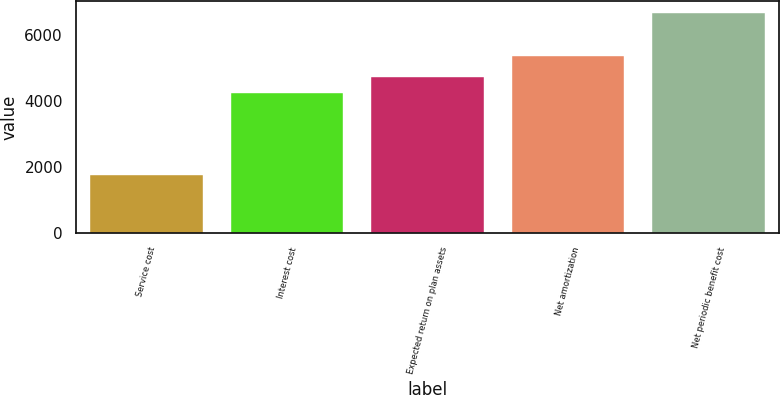Convert chart. <chart><loc_0><loc_0><loc_500><loc_500><bar_chart><fcel>Service cost<fcel>Interest cost<fcel>Expected return on plan assets<fcel>Net amortization<fcel>Net periodic benefit cost<nl><fcel>1756<fcel>4247<fcel>4740.6<fcel>5376<fcel>6692<nl></chart> 